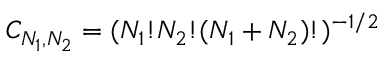Convert formula to latex. <formula><loc_0><loc_0><loc_500><loc_500>C _ { N _ { 1 } , N _ { 2 } } = ( N _ { 1 } ! N _ { 2 } ! ( N _ { 1 } + N _ { 2 } ) ! ) ^ { - 1 / 2 }</formula> 